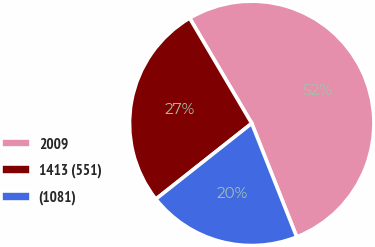Convert chart to OTSL. <chart><loc_0><loc_0><loc_500><loc_500><pie_chart><fcel>2009<fcel>1413 (551)<fcel>(1081)<nl><fcel>52.48%<fcel>27.16%<fcel>20.36%<nl></chart> 